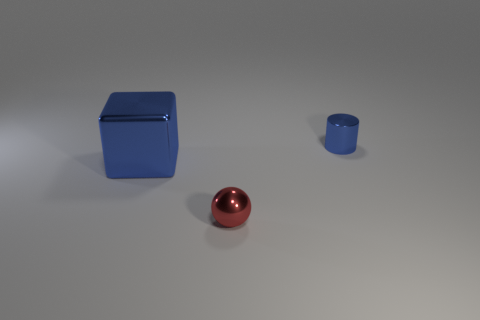What is the shape of the tiny shiny thing that is the same color as the big metal thing?
Your answer should be compact. Cylinder. What number of things are either shiny objects that are in front of the tiny blue thing or tiny green rubber cylinders?
Your answer should be very brief. 2. What number of other things are the same size as the blue shiny block?
Provide a succinct answer. 0. Is the number of tiny blue shiny cylinders that are on the right side of the metallic cube the same as the number of tiny cylinders that are right of the tiny red metallic thing?
Keep it short and to the point. Yes. Is there any other thing that has the same shape as the red thing?
Give a very brief answer. No. There is a thing to the right of the red metal object; is it the same color as the metal ball?
Your answer should be very brief. No. How many small cylinders are the same material as the red ball?
Your response must be concise. 1. Is there a red metallic object behind the tiny shiny thing left of the blue metal thing on the right side of the large blue object?
Make the answer very short. No. What is the shape of the red object?
Offer a terse response. Sphere. Do the blue object that is on the right side of the big blue metallic object and the tiny thing in front of the large blue metal block have the same material?
Your answer should be very brief. Yes. 